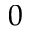Convert formula to latex. <formula><loc_0><loc_0><loc_500><loc_500>0</formula> 